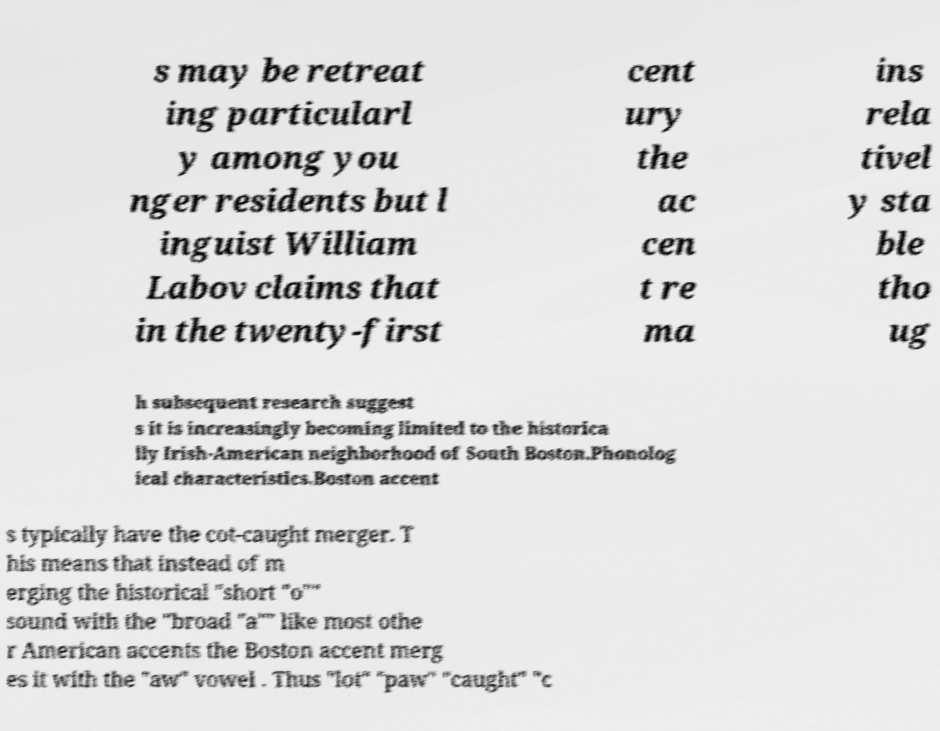What messages or text are displayed in this image? I need them in a readable, typed format. s may be retreat ing particularl y among you nger residents but l inguist William Labov claims that in the twenty-first cent ury the ac cen t re ma ins rela tivel y sta ble tho ug h subsequent research suggest s it is increasingly becoming limited to the historica lly Irish-American neighborhood of South Boston.Phonolog ical characteristics.Boston accent s typically have the cot-caught merger. T his means that instead of m erging the historical "short "o"" sound with the "broad "a"" like most othe r American accents the Boston accent merg es it with the "aw" vowel . Thus "lot" "paw" "caught" "c 